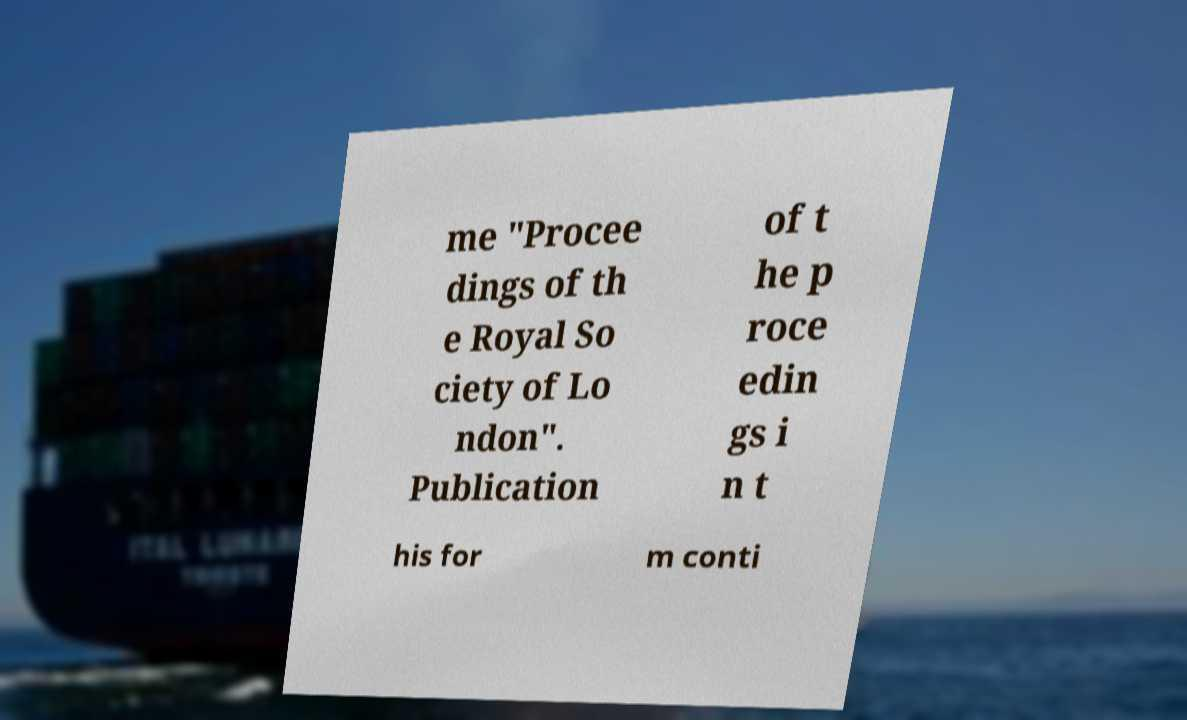Can you accurately transcribe the text from the provided image for me? me "Procee dings of th e Royal So ciety of Lo ndon". Publication of t he p roce edin gs i n t his for m conti 